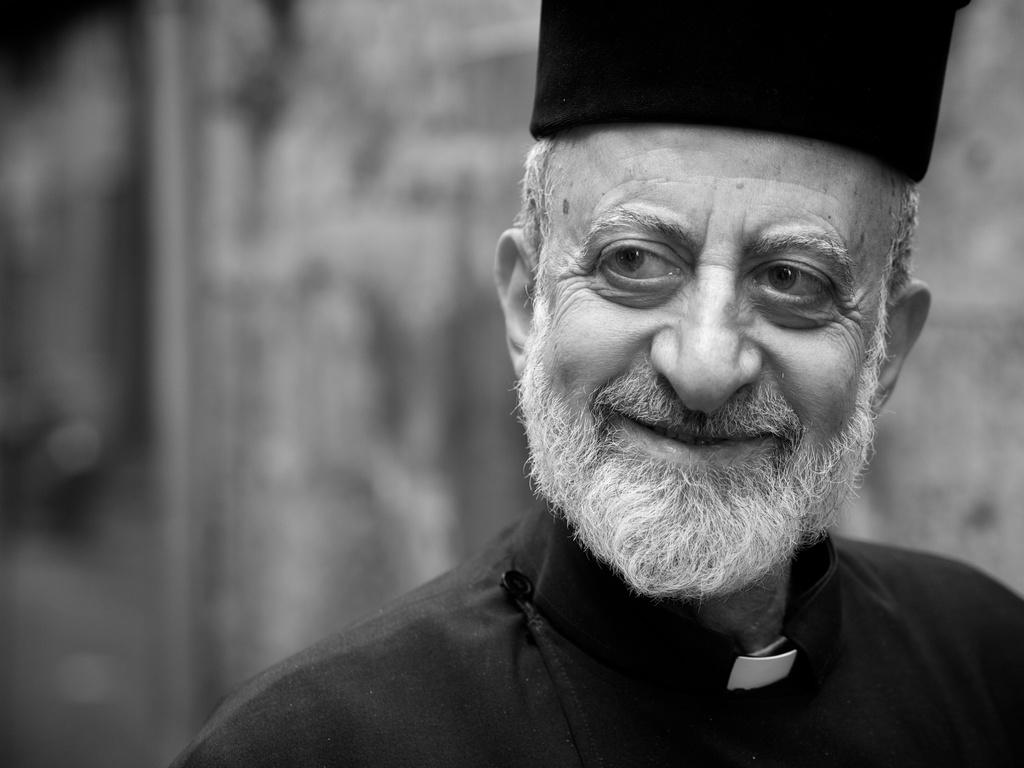What is the color scheme of the image? The image is black and white. Who is present in the image? There is a man in the image. What is the man's facial expression? The man is smiling. Can you describe the background of the image? The background of the image is blurred. What type of rake is the man using in the image? There is no rake present in the image; it features a man with a blurred background. What kind of building can be seen behind the man in the image? There is no building visible in the image; the background is blurred. 